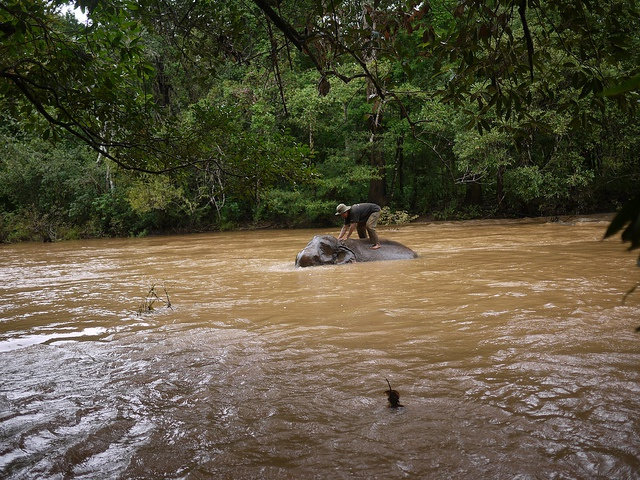Describe the objects in this image and their specific colors. I can see elephant in teal, gray, darkgray, and black tones and people in teal, black, gray, and maroon tones in this image. 